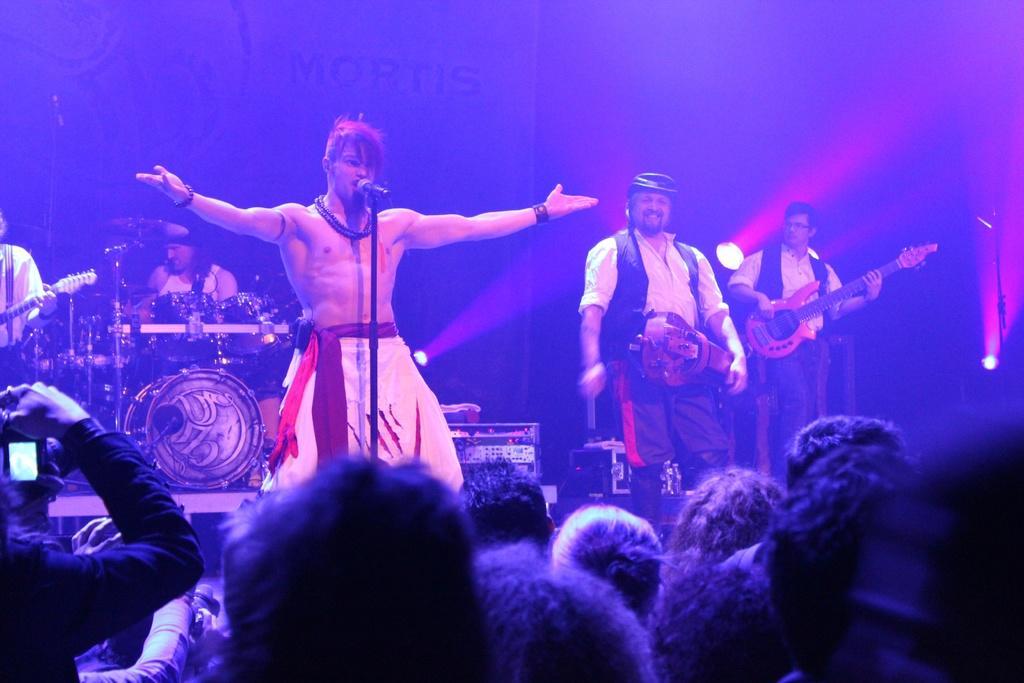Please provide a concise description of this image. The person without a shirt is singing in front of a mic and the persons wearing white dress is playing music on the stage and there are audience in front of them. 